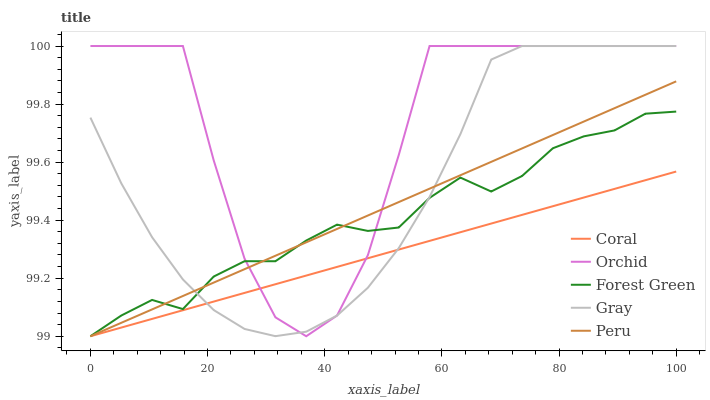Does Coral have the minimum area under the curve?
Answer yes or no. Yes. Does Orchid have the maximum area under the curve?
Answer yes or no. Yes. Does Forest Green have the minimum area under the curve?
Answer yes or no. No. Does Forest Green have the maximum area under the curve?
Answer yes or no. No. Is Peru the smoothest?
Answer yes or no. Yes. Is Orchid the roughest?
Answer yes or no. Yes. Is Coral the smoothest?
Answer yes or no. No. Is Coral the roughest?
Answer yes or no. No. Does Coral have the lowest value?
Answer yes or no. Yes. Does Orchid have the lowest value?
Answer yes or no. No. Does Orchid have the highest value?
Answer yes or no. Yes. Does Forest Green have the highest value?
Answer yes or no. No. Does Orchid intersect Gray?
Answer yes or no. Yes. Is Orchid less than Gray?
Answer yes or no. No. Is Orchid greater than Gray?
Answer yes or no. No. 